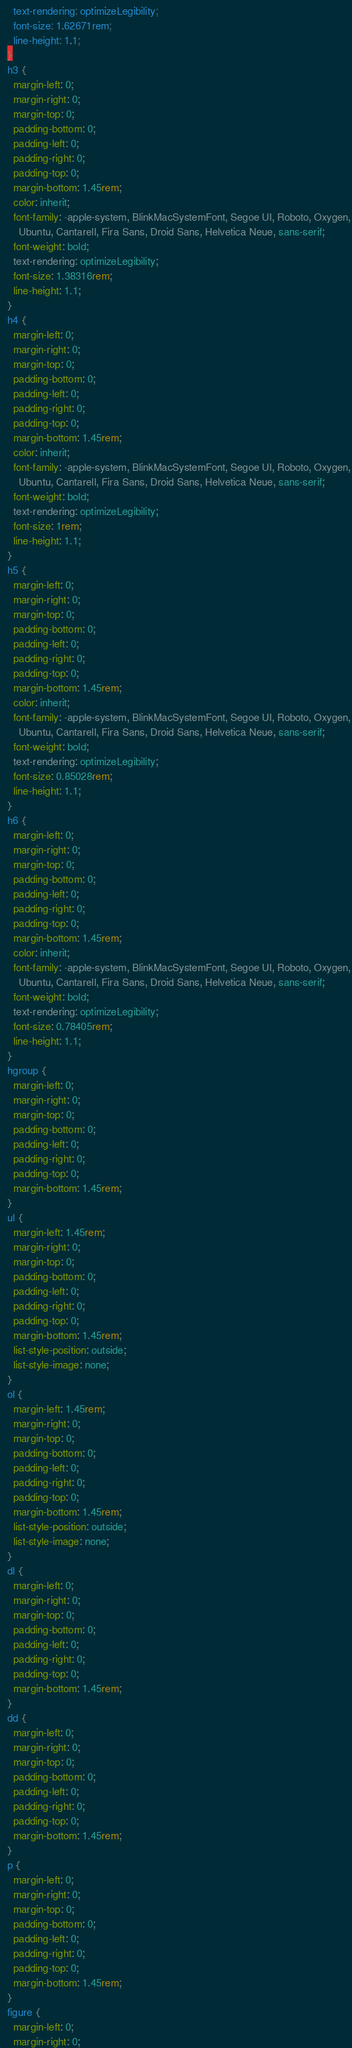<code> <loc_0><loc_0><loc_500><loc_500><_CSS_>    text-rendering: optimizeLegibility;
    font-size: 1.62671rem;
    line-height: 1.1;
  }
  h3 {
    margin-left: 0;
    margin-right: 0;
    margin-top: 0;
    padding-bottom: 0;
    padding-left: 0;
    padding-right: 0;
    padding-top: 0;
    margin-bottom: 1.45rem;
    color: inherit;
    font-family: -apple-system, BlinkMacSystemFont, Segoe UI, Roboto, Oxygen,
      Ubuntu, Cantarell, Fira Sans, Droid Sans, Helvetica Neue, sans-serif;
    font-weight: bold;
    text-rendering: optimizeLegibility;
    font-size: 1.38316rem;
    line-height: 1.1;
  }
  h4 {
    margin-left: 0;
    margin-right: 0;
    margin-top: 0;
    padding-bottom: 0;
    padding-left: 0;
    padding-right: 0;
    padding-top: 0;
    margin-bottom: 1.45rem;
    color: inherit;
    font-family: -apple-system, BlinkMacSystemFont, Segoe UI, Roboto, Oxygen,
      Ubuntu, Cantarell, Fira Sans, Droid Sans, Helvetica Neue, sans-serif;
    font-weight: bold;
    text-rendering: optimizeLegibility;
    font-size: 1rem;
    line-height: 1.1;
  }
  h5 {
    margin-left: 0;
    margin-right: 0;
    margin-top: 0;
    padding-bottom: 0;
    padding-left: 0;
    padding-right: 0;
    padding-top: 0;
    margin-bottom: 1.45rem;
    color: inherit;
    font-family: -apple-system, BlinkMacSystemFont, Segoe UI, Roboto, Oxygen,
      Ubuntu, Cantarell, Fira Sans, Droid Sans, Helvetica Neue, sans-serif;
    font-weight: bold;
    text-rendering: optimizeLegibility;
    font-size: 0.85028rem;
    line-height: 1.1;
  }
  h6 {
    margin-left: 0;
    margin-right: 0;
    margin-top: 0;
    padding-bottom: 0;
    padding-left: 0;
    padding-right: 0;
    padding-top: 0;
    margin-bottom: 1.45rem;
    color: inherit;
    font-family: -apple-system, BlinkMacSystemFont, Segoe UI, Roboto, Oxygen,
      Ubuntu, Cantarell, Fira Sans, Droid Sans, Helvetica Neue, sans-serif;
    font-weight: bold;
    text-rendering: optimizeLegibility;
    font-size: 0.78405rem;
    line-height: 1.1;
  }
  hgroup {
    margin-left: 0;
    margin-right: 0;
    margin-top: 0;
    padding-bottom: 0;
    padding-left: 0;
    padding-right: 0;
    padding-top: 0;
    margin-bottom: 1.45rem;
  }
  ul {
    margin-left: 1.45rem;
    margin-right: 0;
    margin-top: 0;
    padding-bottom: 0;
    padding-left: 0;
    padding-right: 0;
    padding-top: 0;
    margin-bottom: 1.45rem;
    list-style-position: outside;
    list-style-image: none;
  }
  ol {
    margin-left: 1.45rem;
    margin-right: 0;
    margin-top: 0;
    padding-bottom: 0;
    padding-left: 0;
    padding-right: 0;
    padding-top: 0;
    margin-bottom: 1.45rem;
    list-style-position: outside;
    list-style-image: none;
  }
  dl {
    margin-left: 0;
    margin-right: 0;
    margin-top: 0;
    padding-bottom: 0;
    padding-left: 0;
    padding-right: 0;
    padding-top: 0;
    margin-bottom: 1.45rem;
  }
  dd {
    margin-left: 0;
    margin-right: 0;
    margin-top: 0;
    padding-bottom: 0;
    padding-left: 0;
    padding-right: 0;
    padding-top: 0;
    margin-bottom: 1.45rem;
  }
  p {
    margin-left: 0;
    margin-right: 0;
    margin-top: 0;
    padding-bottom: 0;
    padding-left: 0;
    padding-right: 0;
    padding-top: 0;
    margin-bottom: 1.45rem;
  }
  figure {
    margin-left: 0;
    margin-right: 0;</code> 